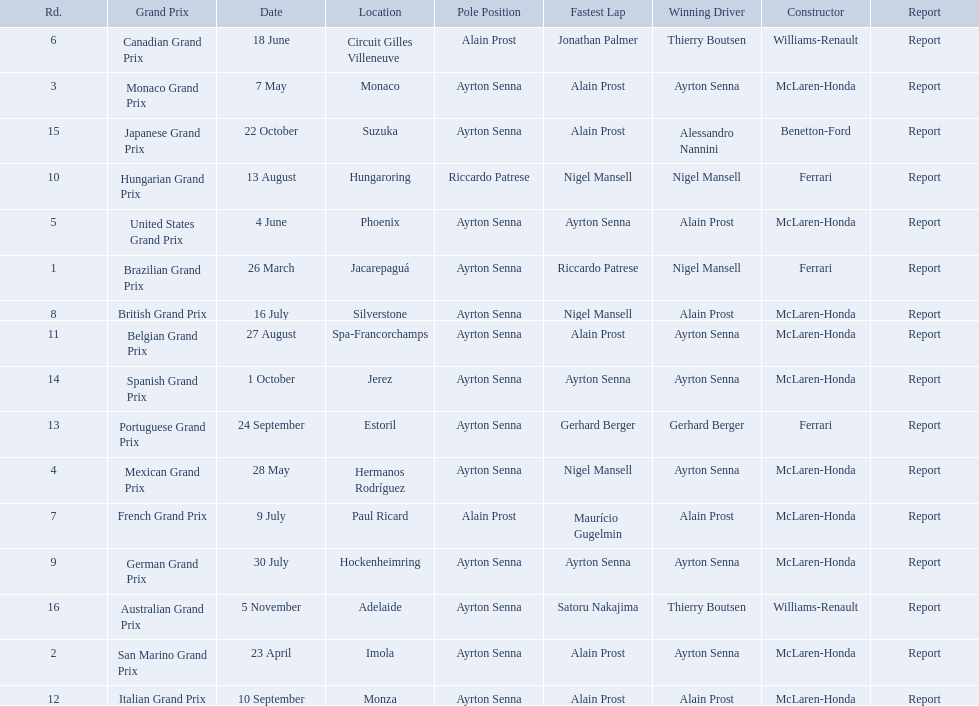Who won the spanish grand prix? McLaren-Honda. Who won the italian grand prix? McLaren-Honda. What grand prix did benneton-ford win? Japanese Grand Prix. 